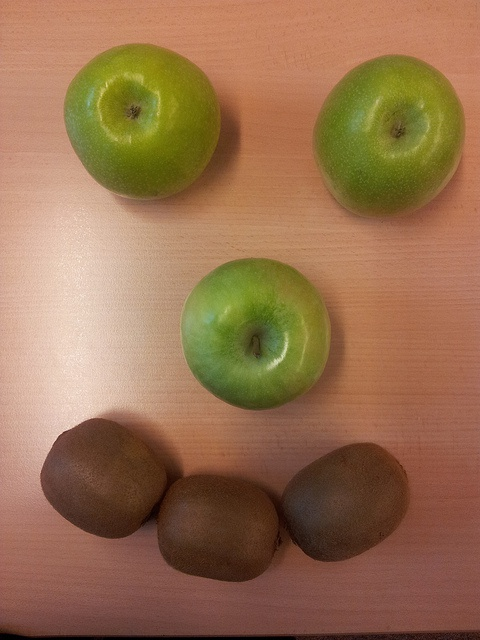Describe the objects in this image and their specific colors. I can see apple in salmon and olive tones, apple in salmon and olive tones, and apple in salmon and olive tones in this image. 